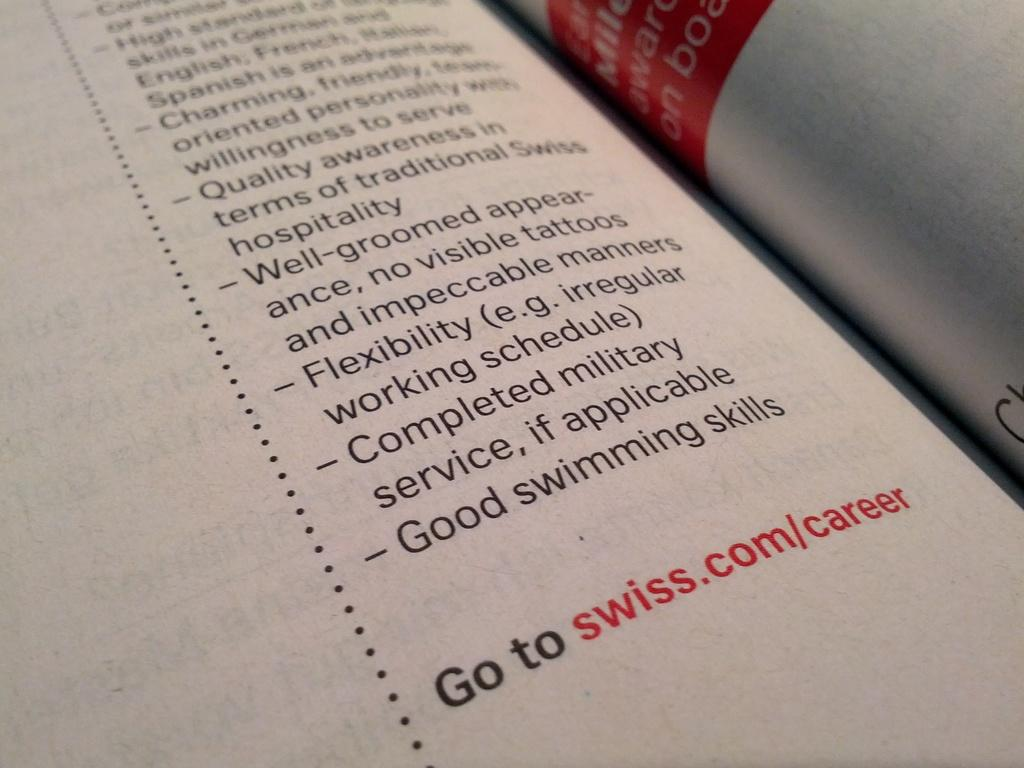<image>
Render a clear and concise summary of the photo. A paper shows the requirements for a job and to go swiss.com/career 